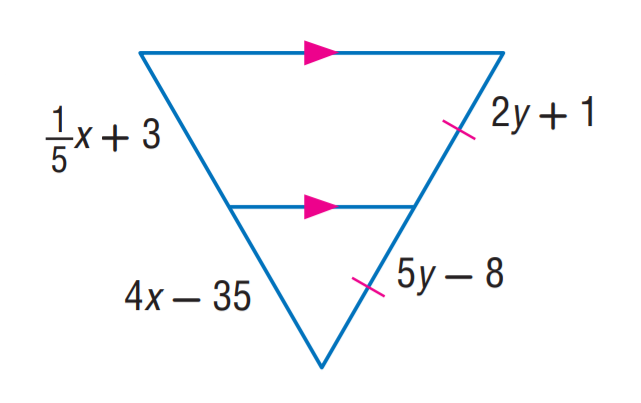Answer the mathemtical geometry problem and directly provide the correct option letter.
Question: Find x.
Choices: A: 5 B: 8 C: 10 D: 12 C 